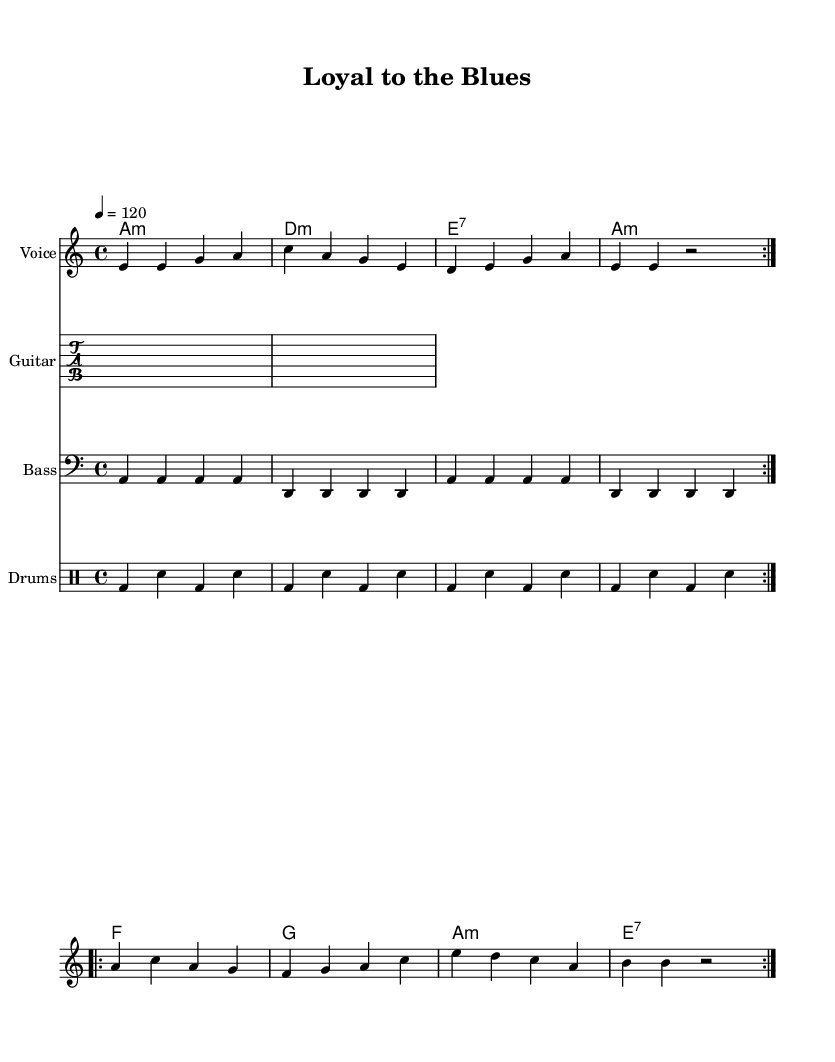What is the key signature of this music? The key signature is A minor, indicated by the absence of sharps or flats next to the clef sign.
Answer: A minor What is the time signature of this music? The time signature is 4/4, shown at the beginning of the score next to the clef, indicating four beats per measure.
Answer: 4/4 What is the tempo marking for this piece? The tempo marking is 120 beats per minute, indicated by the "4 = 120" at the beginning of the score.
Answer: 120 How many times is the first melody section repeated? The first melody section is repeated 2 times, as indicated by the use of "volta" in the repeat markings.
Answer: 2 What type of chord is used at the beginning of the progression? The first chord is an A minor chord, specified as "a1:m" in the chord symbols above the staff.
Answer: A minor How do the themes of friendship and loyalty manifest in the lyrics? The themes manifest through phrases like "standing by your side" and "friendship's strong," illustrating emotional support and loyalty.
Answer: Emotional support 